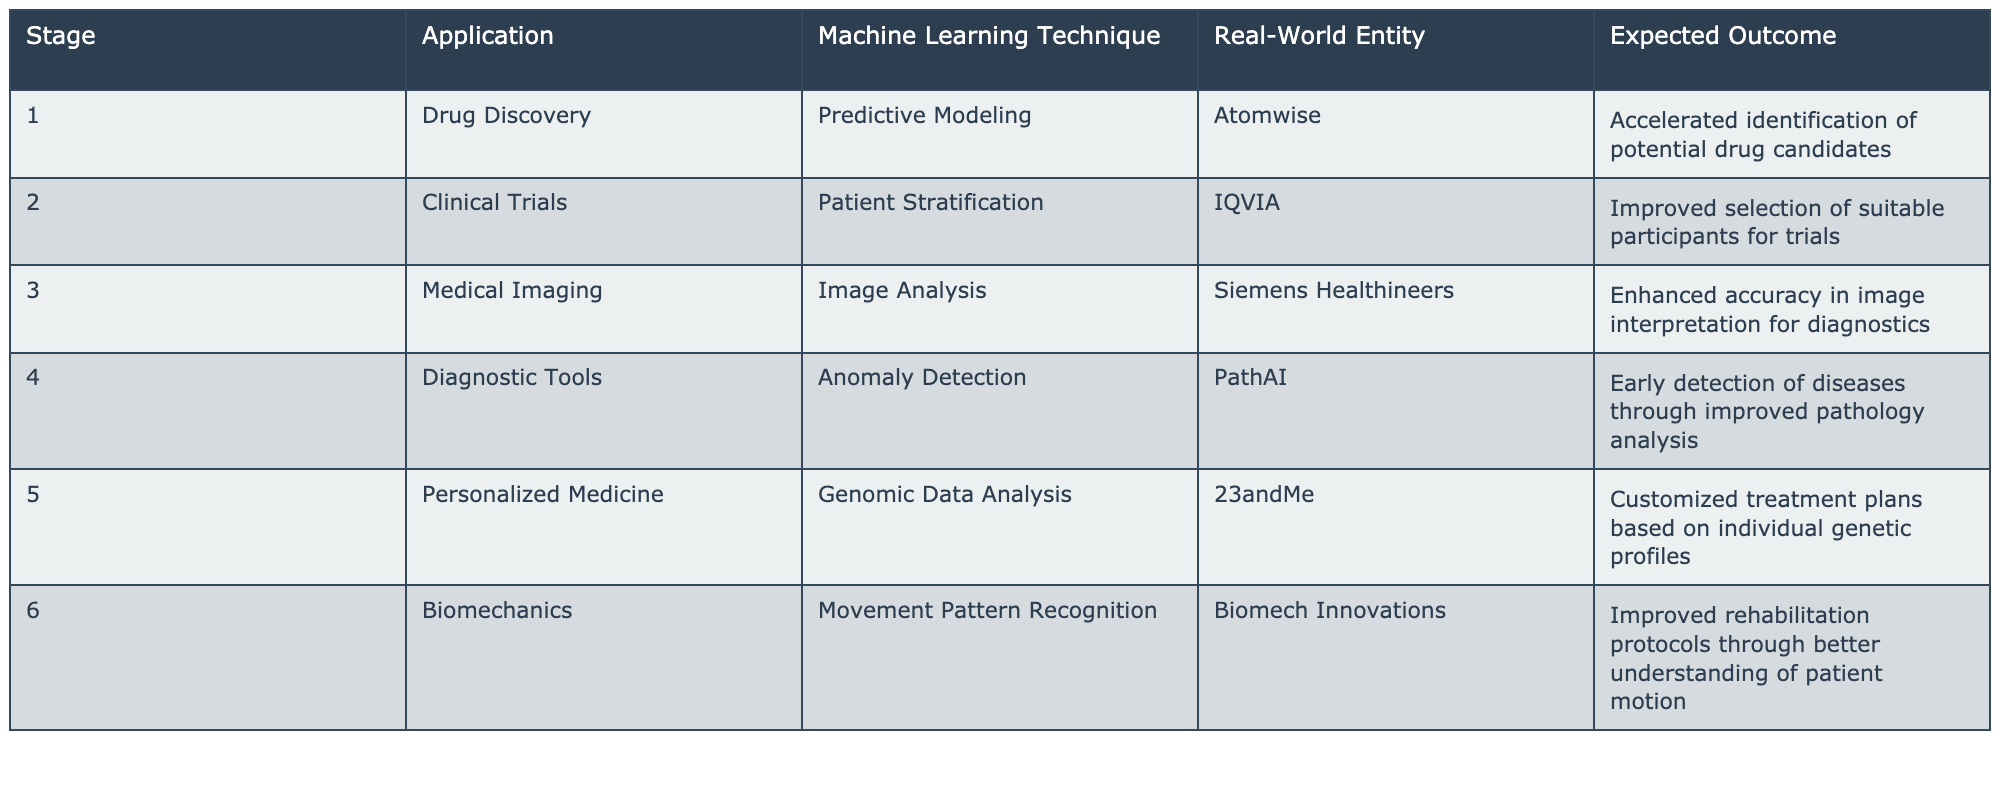What is the expected outcome for Drug Discovery? The table states that the expected outcome for Drug Discovery is "Accelerated identification of potential drug candidates."
Answer: Accelerated identification of potential drug candidates How many applications are listed for clinical trials? Referring to the table, there is only one application listed under the Clinical Trials stage, which is "Patient Stratification."
Answer: One application Is there any application related to personalized medicine in the table? The table includes "Personalized Medicine" as a stage, which has a specific application, "Genomic Data Analysis." Therefore, the answer is yes.
Answer: Yes What are the expected outcomes for Diagnostic Tools, and which entity is associated with it? The table states that the expected outcome for Diagnostic Tools is "Early detection of diseases through improved pathology analysis" and it is associated with the entity "PathAI."
Answer: Early detection of diseases through improved pathology analysis; PathAI Which machine learning technique is employed in Biomechanics and what is its expected outcome? According to the table, the technique used in Biomechanics is "Movement Pattern Recognition," and the expected outcome is "Improved rehabilitation protocols through better understanding of patient motion."
Answer: Movement Pattern Recognition; Improved rehabilitation protocols through better understanding of patient motion What is the common expected outcome for applications related to medical imaging, and which company is mentioned? The common expected outcome for Medical Imaging is "Enhanced accuracy in image interpretation for diagnostics," and the company mentioned is "Siemens Healthineers."
Answer: Enhanced accuracy in image interpretation for diagnostics; Siemens Healthineers If you were to group all applications by their machine learning technique, how many different techniques would you find? There are five unique machine learning techniques listed: Predictive Modeling, Patient Stratification, Image Analysis, Anomaly Detection, Genomic Data Analysis, and Movement Pattern Recognition. Therefore, the total count of different techniques is 6.
Answer: Six techniques How does the expected outcome of Clinical Trials relate to that of Drug Discovery? Clinical Trials' expected outcome is improved selection of suitable participants for trials, while Drug Discovery focuses on accelerated identification of potential drug candidates. Both outcomes aim to enhance overall efficiency in the drug development process.
Answer: They both aim to enhance efficiency in drug development Is there an application in the table that focuses on early detection? The table shows that "Diagnostic Tools" focuses on early detection of diseases through improved pathology analysis, making this a true statement.
Answer: Yes 